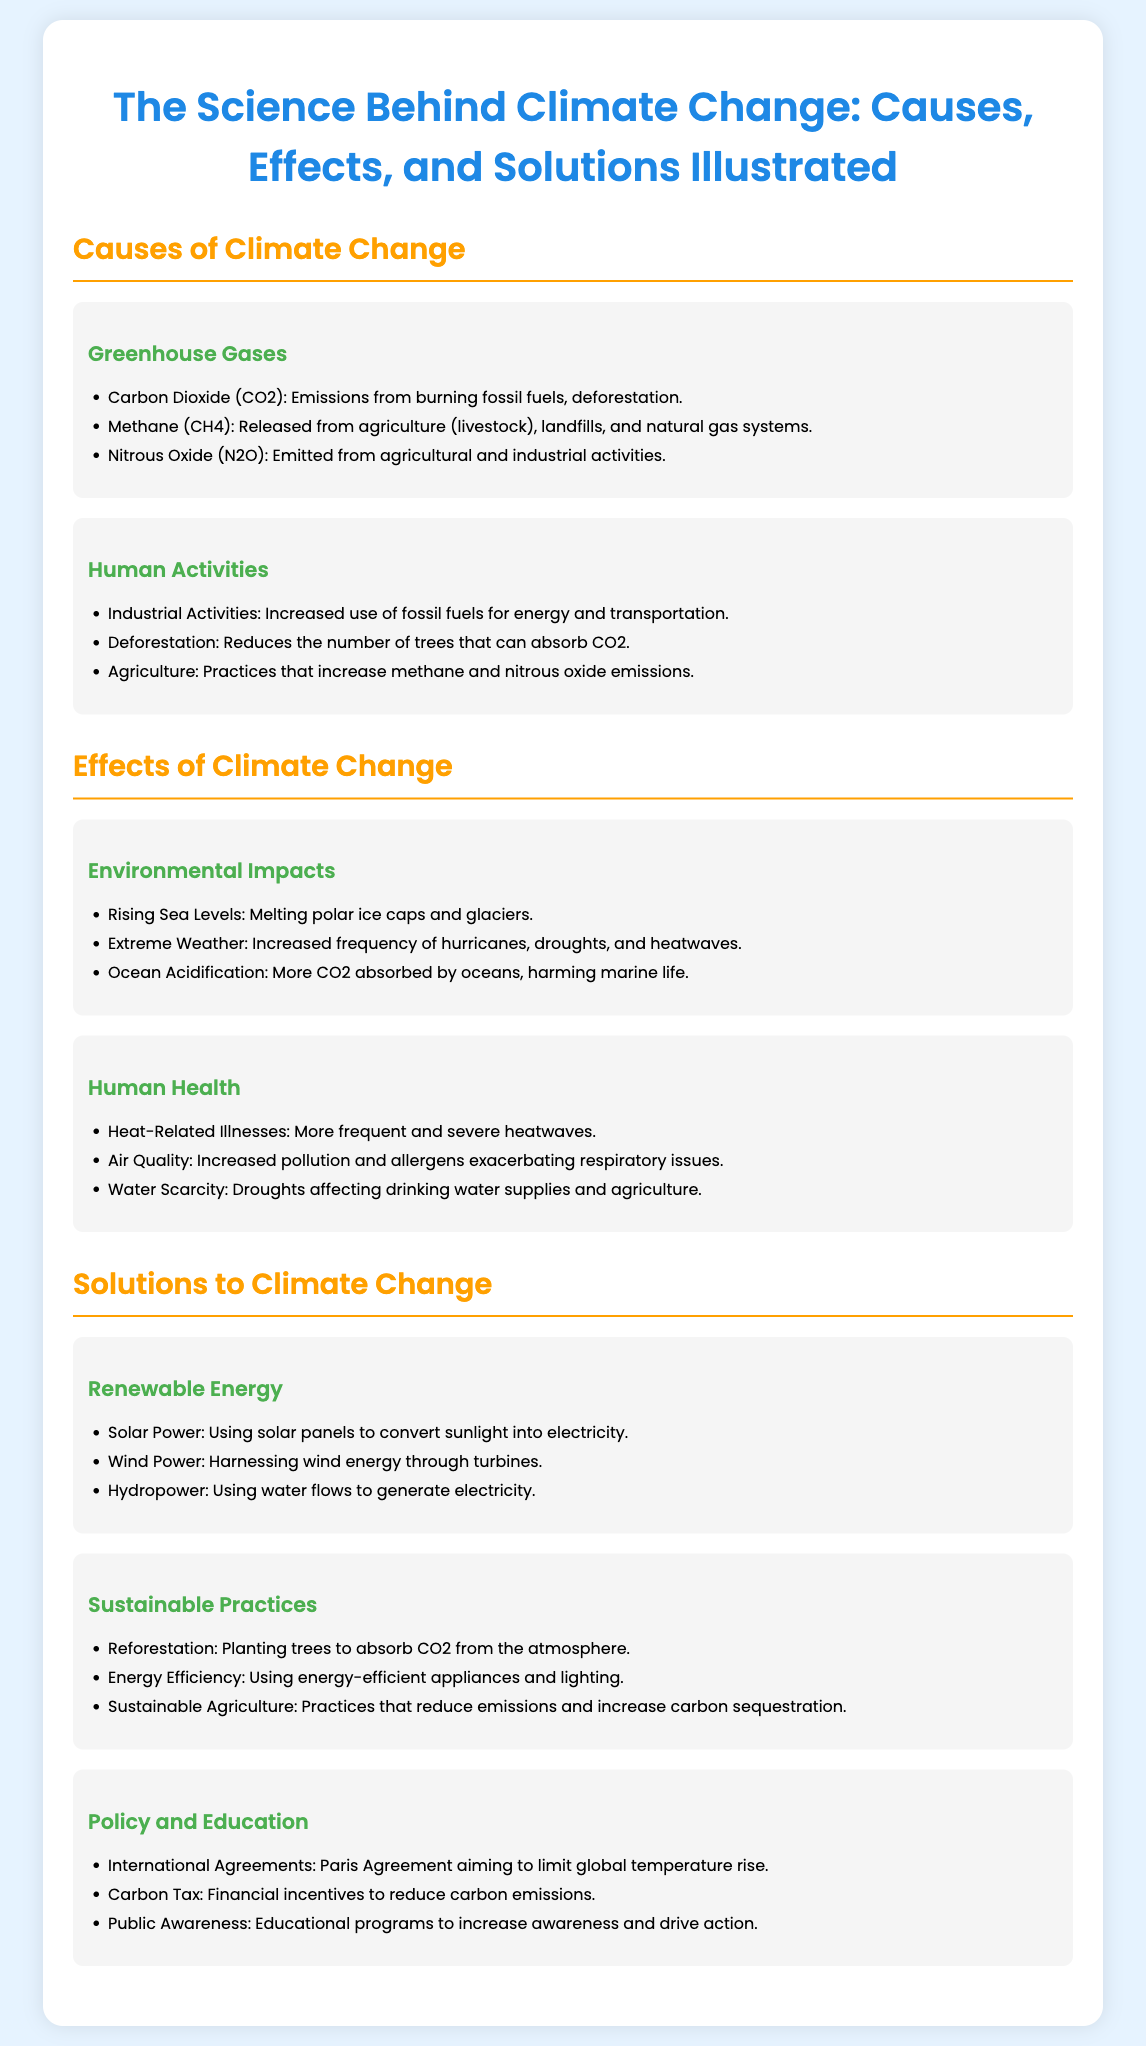What are the three main greenhouse gases? The greenhouse gases listed in the document are Carbon Dioxide, Methane, and Nitrous Oxide.
Answer: Carbon Dioxide, Methane, Nitrous Oxide What human activity contributes to increased methane emissions? The document states that livestock in agriculture is a major contributor to methane emissions.
Answer: Agriculture (livestock) What environmental impact is caused by melting polar ice caps? The rising sea levels are a result of melting polar ice caps and glaciers, as mentioned in the document.
Answer: Rising Sea Levels What are two types of renewable energy mentioned? The document lists Solar Power and Wind Power as examples of renewable energy.
Answer: Solar Power, Wind Power What is one solution to climate change involving trees? The document suggests reforestation as a solution to climate change by planting trees.
Answer: Reforestation What policy aims to limit global temperature rise? According to the document, the Paris Agreement is an international policy aimed at limiting temperature rise.
Answer: Paris Agreement 